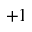<formula> <loc_0><loc_0><loc_500><loc_500>+ 1</formula> 